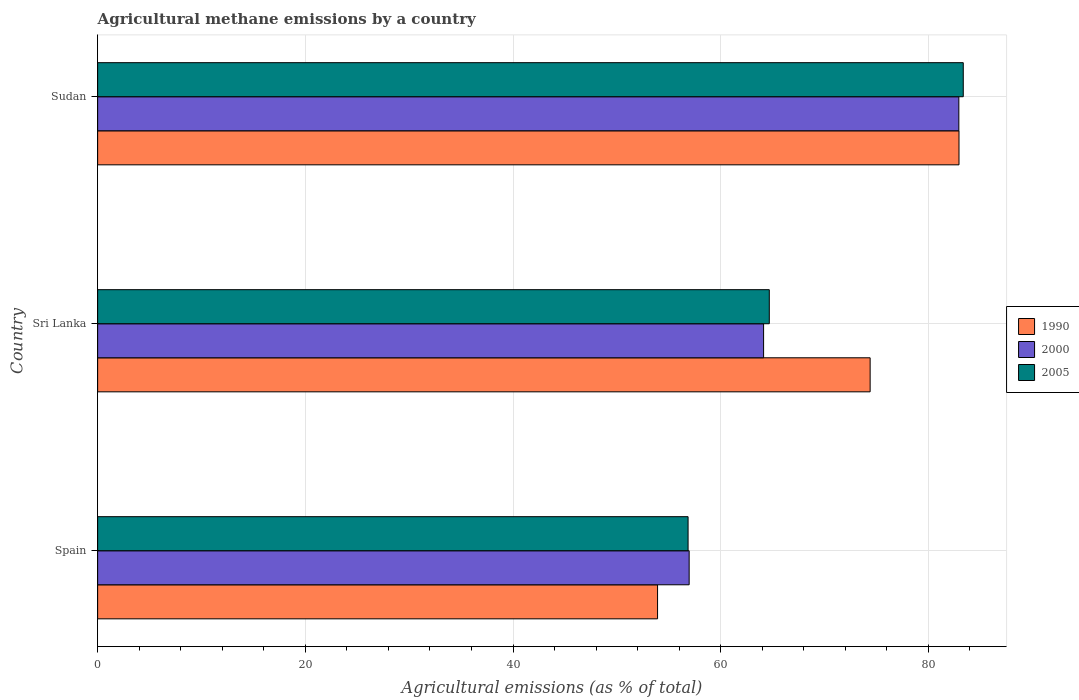How many different coloured bars are there?
Your response must be concise. 3. How many groups of bars are there?
Keep it short and to the point. 3. Are the number of bars per tick equal to the number of legend labels?
Provide a short and direct response. Yes. Are the number of bars on each tick of the Y-axis equal?
Provide a short and direct response. Yes. How many bars are there on the 3rd tick from the top?
Provide a short and direct response. 3. How many bars are there on the 1st tick from the bottom?
Your response must be concise. 3. What is the label of the 3rd group of bars from the top?
Ensure brevity in your answer.  Spain. What is the amount of agricultural methane emitted in 2000 in Sudan?
Offer a very short reply. 82.93. Across all countries, what is the maximum amount of agricultural methane emitted in 2005?
Your response must be concise. 83.36. Across all countries, what is the minimum amount of agricultural methane emitted in 2000?
Your answer should be compact. 56.96. In which country was the amount of agricultural methane emitted in 2005 maximum?
Offer a terse response. Sudan. In which country was the amount of agricultural methane emitted in 2005 minimum?
Offer a very short reply. Spain. What is the total amount of agricultural methane emitted in 1990 in the graph?
Offer a terse response. 211.26. What is the difference between the amount of agricultural methane emitted in 1990 in Sri Lanka and that in Sudan?
Provide a short and direct response. -8.56. What is the difference between the amount of agricultural methane emitted in 2005 in Sri Lanka and the amount of agricultural methane emitted in 2000 in Spain?
Your answer should be very brief. 7.72. What is the average amount of agricultural methane emitted in 2000 per country?
Make the answer very short. 68.01. What is the difference between the amount of agricultural methane emitted in 1990 and amount of agricultural methane emitted in 2005 in Sudan?
Your answer should be very brief. -0.41. In how many countries, is the amount of agricultural methane emitted in 2005 greater than 80 %?
Ensure brevity in your answer.  1. What is the ratio of the amount of agricultural methane emitted in 2005 in Spain to that in Sri Lanka?
Your answer should be very brief. 0.88. What is the difference between the highest and the second highest amount of agricultural methane emitted in 2000?
Provide a succinct answer. 18.8. What is the difference between the highest and the lowest amount of agricultural methane emitted in 2005?
Offer a terse response. 26.5. Is the sum of the amount of agricultural methane emitted in 2005 in Spain and Sri Lanka greater than the maximum amount of agricultural methane emitted in 1990 across all countries?
Your response must be concise. Yes. Are all the bars in the graph horizontal?
Your response must be concise. Yes. How many countries are there in the graph?
Offer a terse response. 3. What is the difference between two consecutive major ticks on the X-axis?
Offer a very short reply. 20. Are the values on the major ticks of X-axis written in scientific E-notation?
Give a very brief answer. No. Does the graph contain any zero values?
Offer a terse response. No. Does the graph contain grids?
Your answer should be compact. Yes. How many legend labels are there?
Give a very brief answer. 3. What is the title of the graph?
Your response must be concise. Agricultural methane emissions by a country. What is the label or title of the X-axis?
Your answer should be very brief. Agricultural emissions (as % of total). What is the label or title of the Y-axis?
Your answer should be compact. Country. What is the Agricultural emissions (as % of total) of 1990 in Spain?
Ensure brevity in your answer.  53.92. What is the Agricultural emissions (as % of total) of 2000 in Spain?
Your response must be concise. 56.96. What is the Agricultural emissions (as % of total) of 2005 in Spain?
Your answer should be very brief. 56.86. What is the Agricultural emissions (as % of total) in 1990 in Sri Lanka?
Offer a very short reply. 74.39. What is the Agricultural emissions (as % of total) of 2000 in Sri Lanka?
Your answer should be very brief. 64.13. What is the Agricultural emissions (as % of total) of 2005 in Sri Lanka?
Provide a short and direct response. 64.68. What is the Agricultural emissions (as % of total) of 1990 in Sudan?
Your answer should be compact. 82.95. What is the Agricultural emissions (as % of total) of 2000 in Sudan?
Give a very brief answer. 82.93. What is the Agricultural emissions (as % of total) of 2005 in Sudan?
Give a very brief answer. 83.36. Across all countries, what is the maximum Agricultural emissions (as % of total) of 1990?
Your answer should be compact. 82.95. Across all countries, what is the maximum Agricultural emissions (as % of total) of 2000?
Provide a short and direct response. 82.93. Across all countries, what is the maximum Agricultural emissions (as % of total) of 2005?
Provide a short and direct response. 83.36. Across all countries, what is the minimum Agricultural emissions (as % of total) in 1990?
Provide a succinct answer. 53.92. Across all countries, what is the minimum Agricultural emissions (as % of total) of 2000?
Provide a short and direct response. 56.96. Across all countries, what is the minimum Agricultural emissions (as % of total) of 2005?
Ensure brevity in your answer.  56.86. What is the total Agricultural emissions (as % of total) of 1990 in the graph?
Offer a very short reply. 211.26. What is the total Agricultural emissions (as % of total) in 2000 in the graph?
Give a very brief answer. 204.02. What is the total Agricultural emissions (as % of total) of 2005 in the graph?
Your answer should be very brief. 204.9. What is the difference between the Agricultural emissions (as % of total) of 1990 in Spain and that in Sri Lanka?
Your answer should be compact. -20.47. What is the difference between the Agricultural emissions (as % of total) in 2000 in Spain and that in Sri Lanka?
Keep it short and to the point. -7.17. What is the difference between the Agricultural emissions (as % of total) of 2005 in Spain and that in Sri Lanka?
Offer a very short reply. -7.82. What is the difference between the Agricultural emissions (as % of total) in 1990 in Spain and that in Sudan?
Offer a very short reply. -29.03. What is the difference between the Agricultural emissions (as % of total) of 2000 in Spain and that in Sudan?
Your response must be concise. -25.97. What is the difference between the Agricultural emissions (as % of total) of 2005 in Spain and that in Sudan?
Your answer should be very brief. -26.5. What is the difference between the Agricultural emissions (as % of total) in 1990 in Sri Lanka and that in Sudan?
Offer a terse response. -8.56. What is the difference between the Agricultural emissions (as % of total) in 2000 in Sri Lanka and that in Sudan?
Your response must be concise. -18.8. What is the difference between the Agricultural emissions (as % of total) in 2005 in Sri Lanka and that in Sudan?
Offer a terse response. -18.68. What is the difference between the Agricultural emissions (as % of total) of 1990 in Spain and the Agricultural emissions (as % of total) of 2000 in Sri Lanka?
Provide a succinct answer. -10.21. What is the difference between the Agricultural emissions (as % of total) in 1990 in Spain and the Agricultural emissions (as % of total) in 2005 in Sri Lanka?
Your response must be concise. -10.76. What is the difference between the Agricultural emissions (as % of total) in 2000 in Spain and the Agricultural emissions (as % of total) in 2005 in Sri Lanka?
Your answer should be very brief. -7.72. What is the difference between the Agricultural emissions (as % of total) of 1990 in Spain and the Agricultural emissions (as % of total) of 2000 in Sudan?
Provide a succinct answer. -29.01. What is the difference between the Agricultural emissions (as % of total) in 1990 in Spain and the Agricultural emissions (as % of total) in 2005 in Sudan?
Provide a short and direct response. -29.44. What is the difference between the Agricultural emissions (as % of total) of 2000 in Spain and the Agricultural emissions (as % of total) of 2005 in Sudan?
Offer a terse response. -26.4. What is the difference between the Agricultural emissions (as % of total) in 1990 in Sri Lanka and the Agricultural emissions (as % of total) in 2000 in Sudan?
Make the answer very short. -8.54. What is the difference between the Agricultural emissions (as % of total) in 1990 in Sri Lanka and the Agricultural emissions (as % of total) in 2005 in Sudan?
Keep it short and to the point. -8.97. What is the difference between the Agricultural emissions (as % of total) of 2000 in Sri Lanka and the Agricultural emissions (as % of total) of 2005 in Sudan?
Provide a short and direct response. -19.23. What is the average Agricultural emissions (as % of total) in 1990 per country?
Make the answer very short. 70.42. What is the average Agricultural emissions (as % of total) in 2000 per country?
Make the answer very short. 68.01. What is the average Agricultural emissions (as % of total) of 2005 per country?
Make the answer very short. 68.3. What is the difference between the Agricultural emissions (as % of total) in 1990 and Agricultural emissions (as % of total) in 2000 in Spain?
Your answer should be very brief. -3.04. What is the difference between the Agricultural emissions (as % of total) in 1990 and Agricultural emissions (as % of total) in 2005 in Spain?
Offer a terse response. -2.94. What is the difference between the Agricultural emissions (as % of total) of 2000 and Agricultural emissions (as % of total) of 2005 in Spain?
Make the answer very short. 0.1. What is the difference between the Agricultural emissions (as % of total) in 1990 and Agricultural emissions (as % of total) in 2000 in Sri Lanka?
Your answer should be compact. 10.26. What is the difference between the Agricultural emissions (as % of total) of 1990 and Agricultural emissions (as % of total) of 2005 in Sri Lanka?
Offer a very short reply. 9.71. What is the difference between the Agricultural emissions (as % of total) in 2000 and Agricultural emissions (as % of total) in 2005 in Sri Lanka?
Provide a short and direct response. -0.55. What is the difference between the Agricultural emissions (as % of total) of 1990 and Agricultural emissions (as % of total) of 2000 in Sudan?
Your response must be concise. 0.01. What is the difference between the Agricultural emissions (as % of total) of 1990 and Agricultural emissions (as % of total) of 2005 in Sudan?
Provide a short and direct response. -0.41. What is the difference between the Agricultural emissions (as % of total) of 2000 and Agricultural emissions (as % of total) of 2005 in Sudan?
Your answer should be compact. -0.43. What is the ratio of the Agricultural emissions (as % of total) of 1990 in Spain to that in Sri Lanka?
Your answer should be very brief. 0.72. What is the ratio of the Agricultural emissions (as % of total) of 2000 in Spain to that in Sri Lanka?
Provide a short and direct response. 0.89. What is the ratio of the Agricultural emissions (as % of total) of 2005 in Spain to that in Sri Lanka?
Make the answer very short. 0.88. What is the ratio of the Agricultural emissions (as % of total) of 1990 in Spain to that in Sudan?
Provide a short and direct response. 0.65. What is the ratio of the Agricultural emissions (as % of total) in 2000 in Spain to that in Sudan?
Offer a terse response. 0.69. What is the ratio of the Agricultural emissions (as % of total) in 2005 in Spain to that in Sudan?
Ensure brevity in your answer.  0.68. What is the ratio of the Agricultural emissions (as % of total) in 1990 in Sri Lanka to that in Sudan?
Provide a short and direct response. 0.9. What is the ratio of the Agricultural emissions (as % of total) in 2000 in Sri Lanka to that in Sudan?
Offer a terse response. 0.77. What is the ratio of the Agricultural emissions (as % of total) in 2005 in Sri Lanka to that in Sudan?
Provide a succinct answer. 0.78. What is the difference between the highest and the second highest Agricultural emissions (as % of total) of 1990?
Provide a short and direct response. 8.56. What is the difference between the highest and the second highest Agricultural emissions (as % of total) in 2000?
Make the answer very short. 18.8. What is the difference between the highest and the second highest Agricultural emissions (as % of total) of 2005?
Provide a succinct answer. 18.68. What is the difference between the highest and the lowest Agricultural emissions (as % of total) in 1990?
Provide a short and direct response. 29.03. What is the difference between the highest and the lowest Agricultural emissions (as % of total) of 2000?
Your answer should be very brief. 25.97. What is the difference between the highest and the lowest Agricultural emissions (as % of total) in 2005?
Make the answer very short. 26.5. 